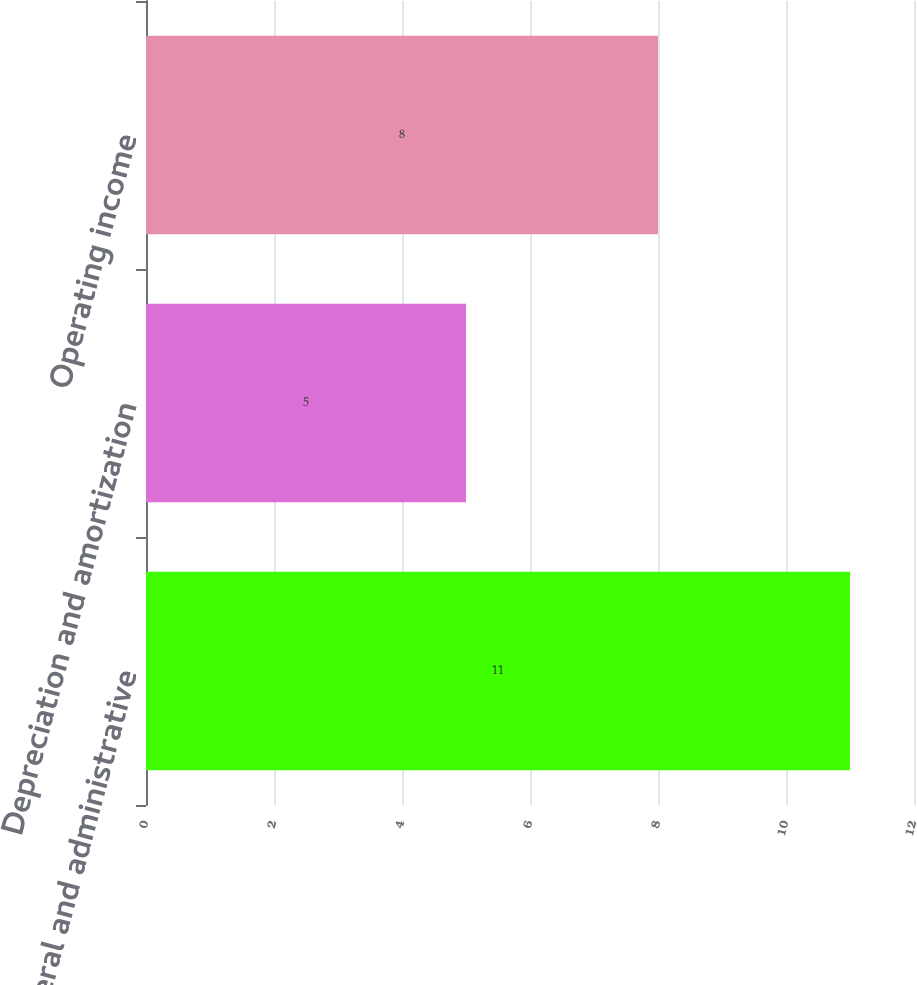<chart> <loc_0><loc_0><loc_500><loc_500><bar_chart><fcel>General and administrative<fcel>Depreciation and amortization<fcel>Operating income<nl><fcel>11<fcel>5<fcel>8<nl></chart> 